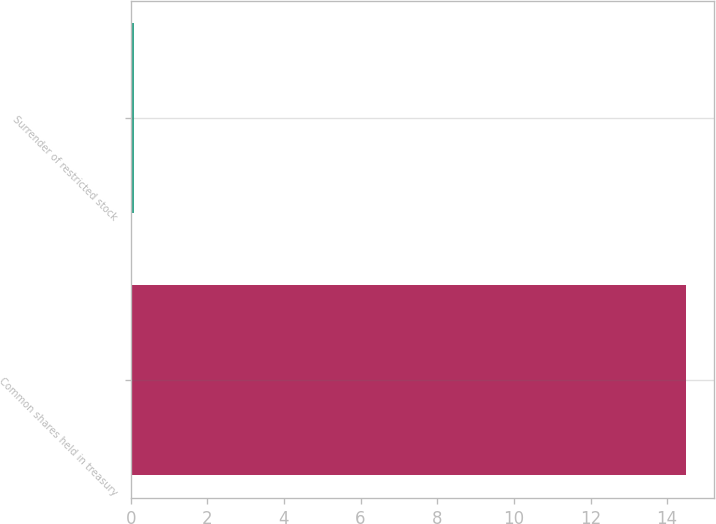Convert chart. <chart><loc_0><loc_0><loc_500><loc_500><bar_chart><fcel>Common shares held in treasury<fcel>Surrender of restricted stock<nl><fcel>14.5<fcel>0.1<nl></chart> 